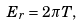Convert formula to latex. <formula><loc_0><loc_0><loc_500><loc_500>E _ { r } = 2 \pi T ,</formula> 